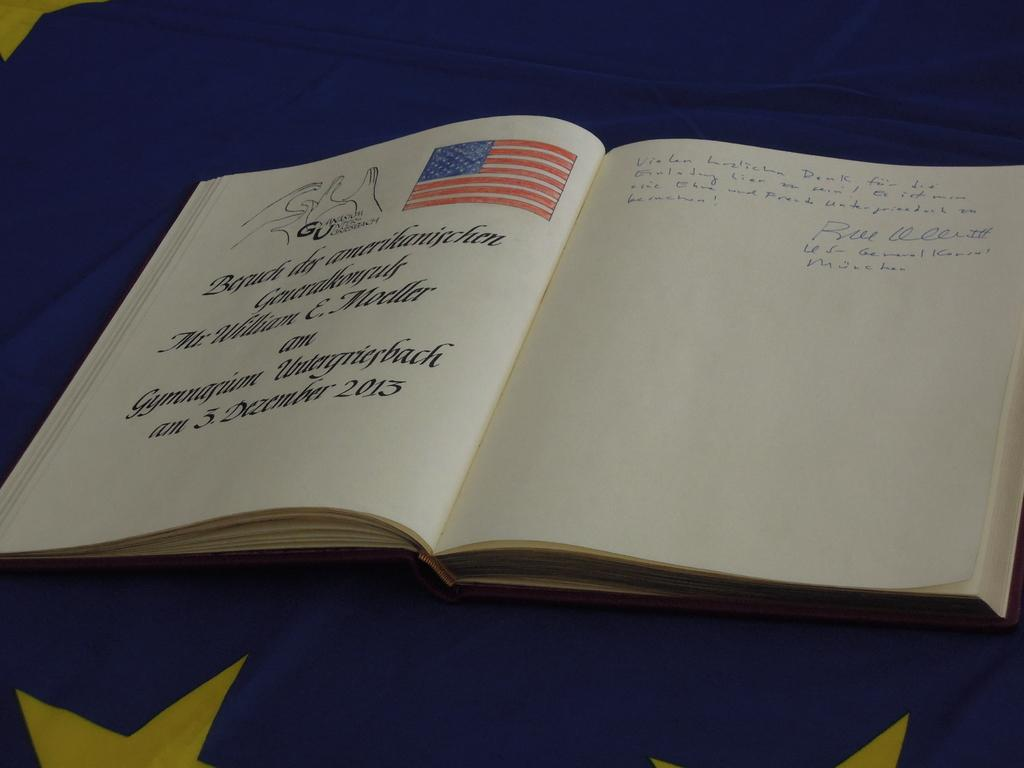Provide a one-sentence caption for the provided image. A book is open to a page with an American page and says 3 December 2013. 